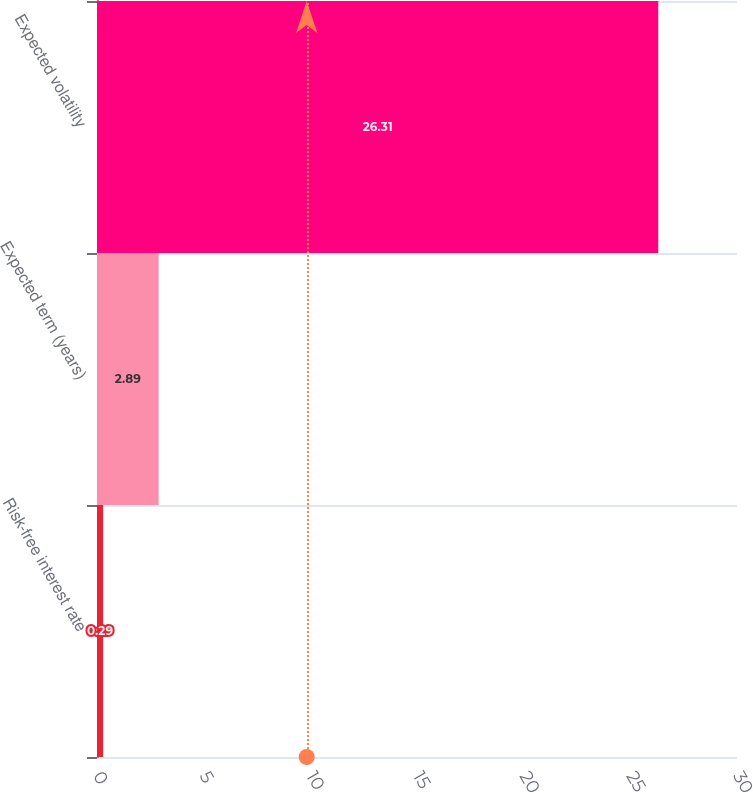Convert chart. <chart><loc_0><loc_0><loc_500><loc_500><bar_chart><fcel>Risk-free interest rate<fcel>Expected term (years)<fcel>Expected volatility<nl><fcel>0.29<fcel>2.89<fcel>26.31<nl></chart> 